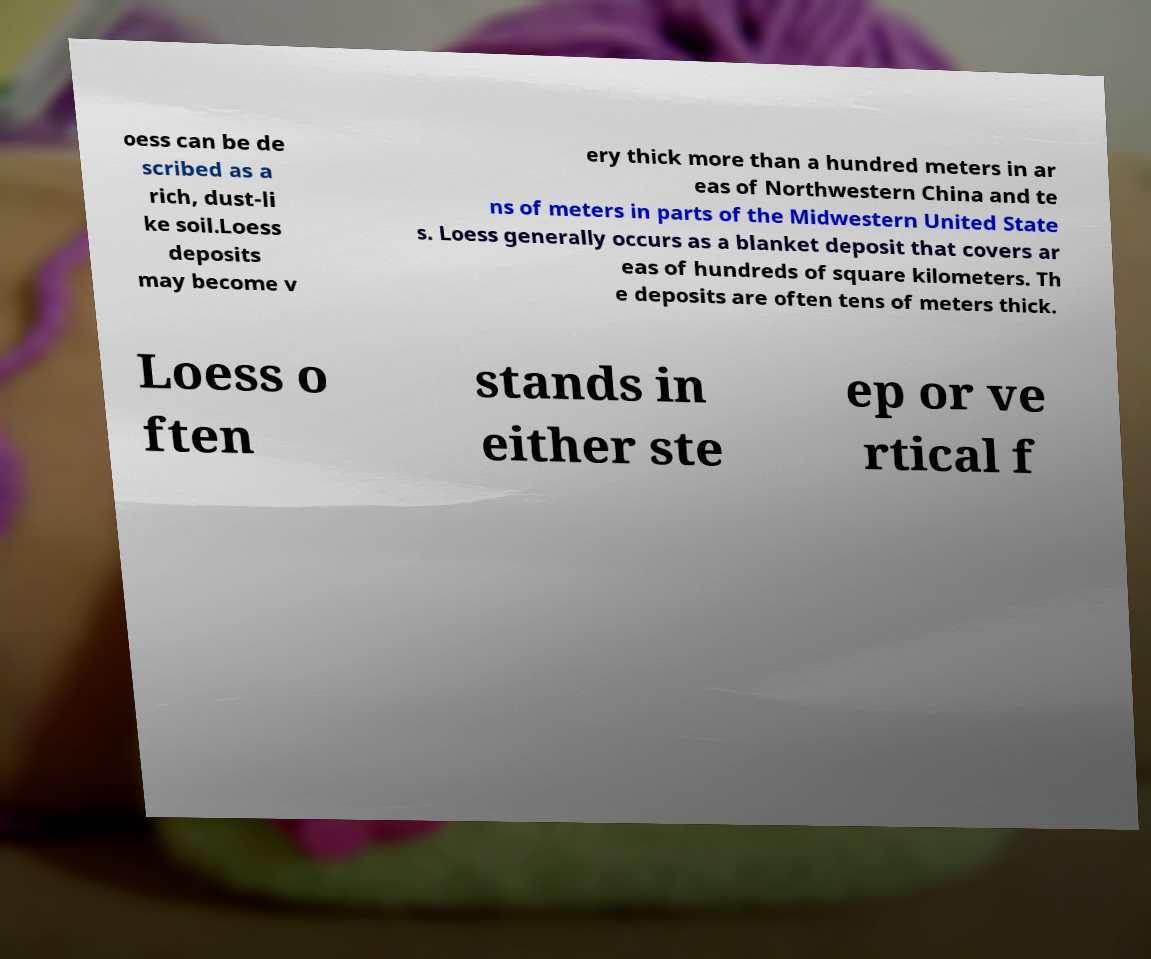For documentation purposes, I need the text within this image transcribed. Could you provide that? oess can be de scribed as a rich, dust-li ke soil.Loess deposits may become v ery thick more than a hundred meters in ar eas of Northwestern China and te ns of meters in parts of the Midwestern United State s. Loess generally occurs as a blanket deposit that covers ar eas of hundreds of square kilometers. Th e deposits are often tens of meters thick. Loess o ften stands in either ste ep or ve rtical f 